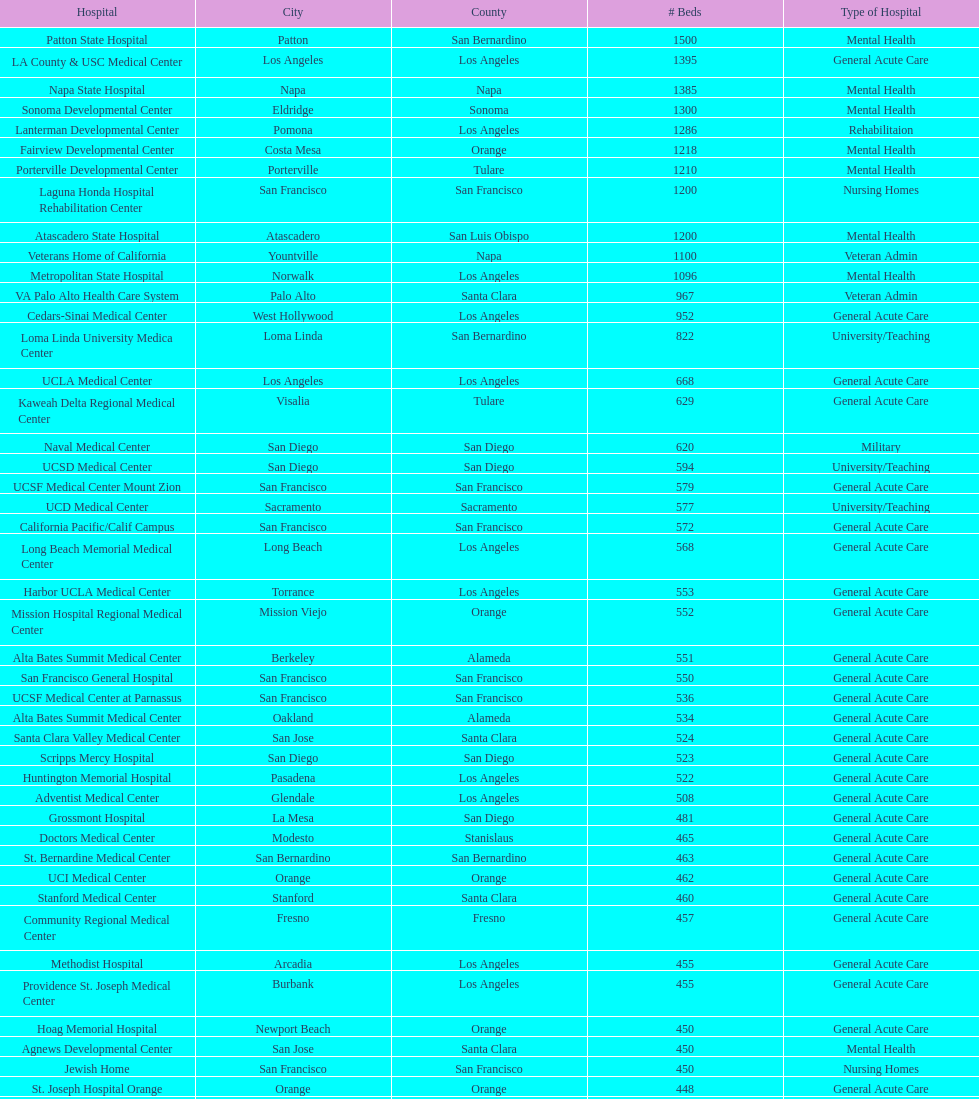Which type of hospitals are the same as grossmont hospital? General Acute Care. 